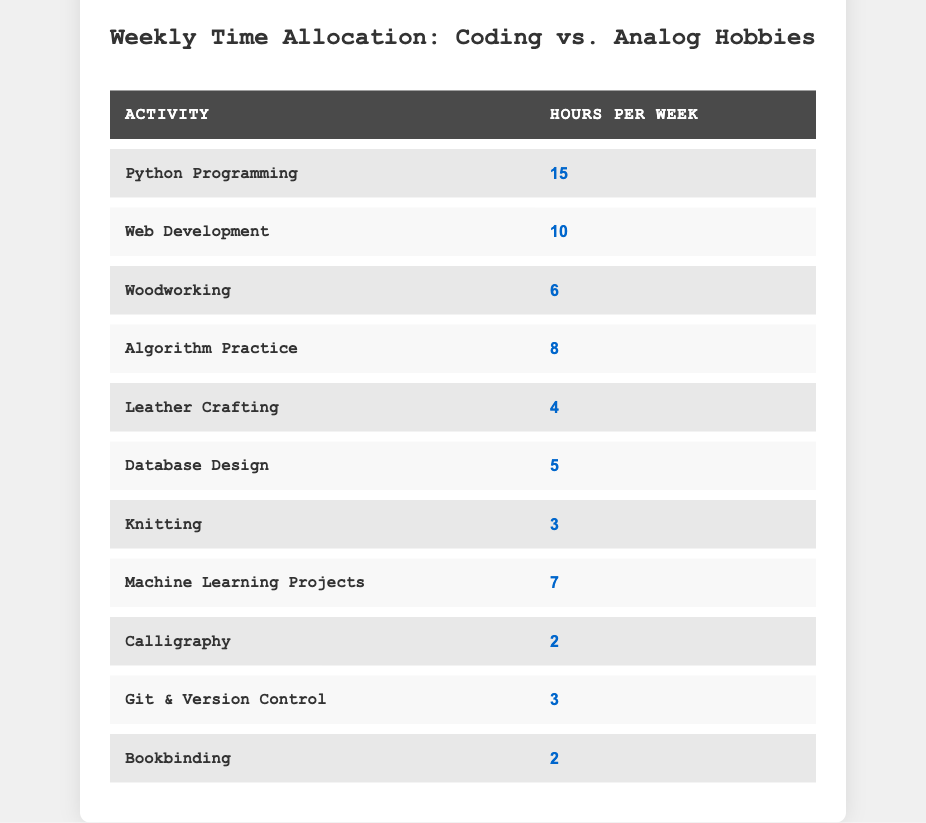What is the total number of hours allocated to Python Programming and Web Development combined? To find the total hours, we need to add the hours for Python Programming (15) and Web Development (10): 15 + 10 = 25.
Answer: 25 How many hours per week are spent on analog hobbies? We sum the hours allocated for each analog hobby: Woodworking (6) + Leather Crafting (4) + Knitting (3) + Calligraphy (2) + Bookbinding (2) = 17.
Answer: 17 Is the time spent on Machine Learning Projects greater than that spent on Algorithm Practice? Machine Learning Projects takes 7 hours and Algorithm Practice takes 8 hours. Since 7 is less than 8, the answer is no.
Answer: No Which coding activity has the lowest time allocation? Looking at the coding activities: Python Programming (15), Web Development (10), Algorithm Practice (8), Database Design (5), Machine Learning Projects (7), and Git & Version Control (3), we find that Git & Version Control (3) has the lowest hours.
Answer: Git & Version Control What is the average time spent on analog hobbies per week? There are 5 analog activities with the following hours: 6, 4, 3, 2, and 2. The total is 17 hours (from previous calculation). The average is calculated by dividing the total by the number of activities: 17 / 5 = 3.4.
Answer: 3.4 Are there more hours allocated to coding activities than analog hobbies? The total hours for coding activities is 15 + 10 + 8 + 5 + 7 + 3 = 48. For analog hobbies, the total is 17 (as calculated earlier). Since 48 is greater than 17, the answer is yes.
Answer: Yes Which analog hobby takes the most time? Comparing the analog activities: Woodworking (6), Leather Crafting (4), Knitting (3), Calligraphy (2), and Bookbinding (2), we see that Woodworking has the highest allocation with 6 hours.
Answer: Woodworking What is the sum of hours spent on both Git & Version Control and Calligraphy? The hours for Git & Version Control is 3 and for Calligraphy is 2. Adding them gives: 3 + 2 = 5.
Answer: 5 Which coding activity has the highest time allocation? The coding activities and their hours are: Python Programming (15), Web Development (10), Algorithm Practice (8), Database Design (5), Machine Learning Projects (7), and Git & Version Control (3). Python Programming has the highest hours at 15.
Answer: Python Programming 